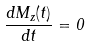Convert formula to latex. <formula><loc_0><loc_0><loc_500><loc_500>\frac { d M _ { z } ( t ) } { d t } = 0</formula> 